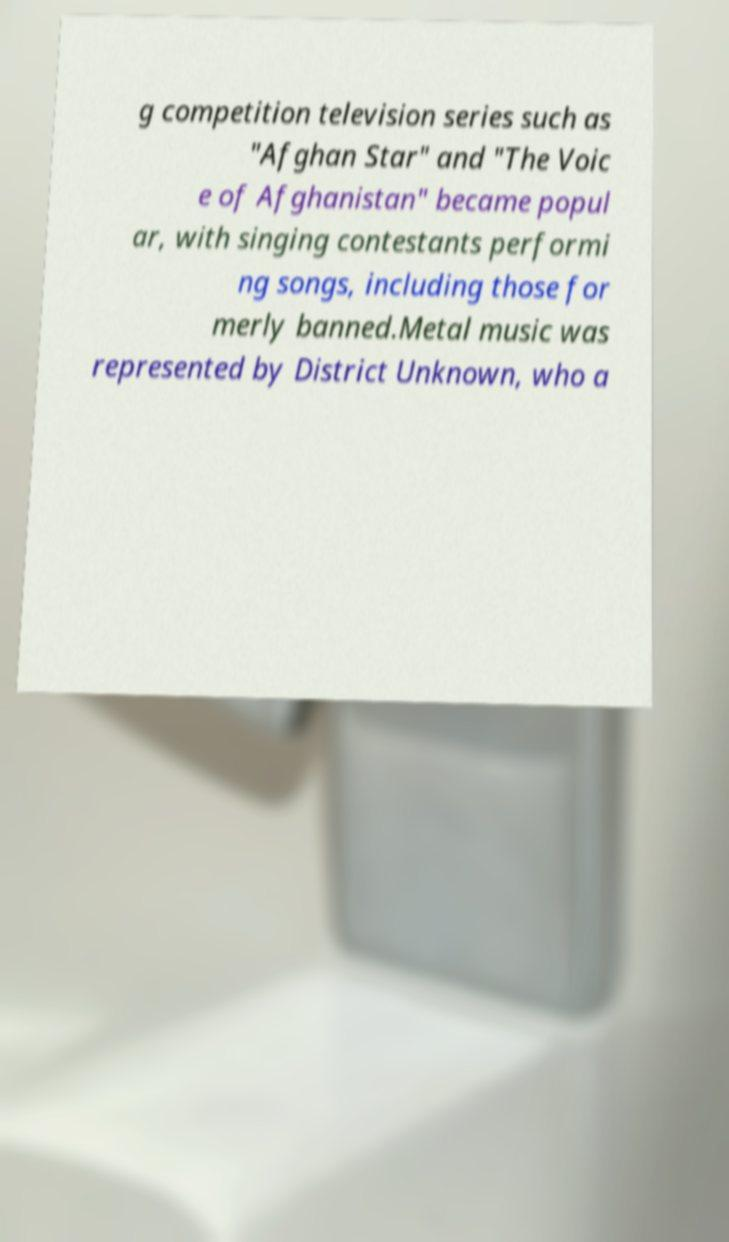Could you extract and type out the text from this image? g competition television series such as "Afghan Star" and "The Voic e of Afghanistan" became popul ar, with singing contestants performi ng songs, including those for merly banned.Metal music was represented by District Unknown, who a 